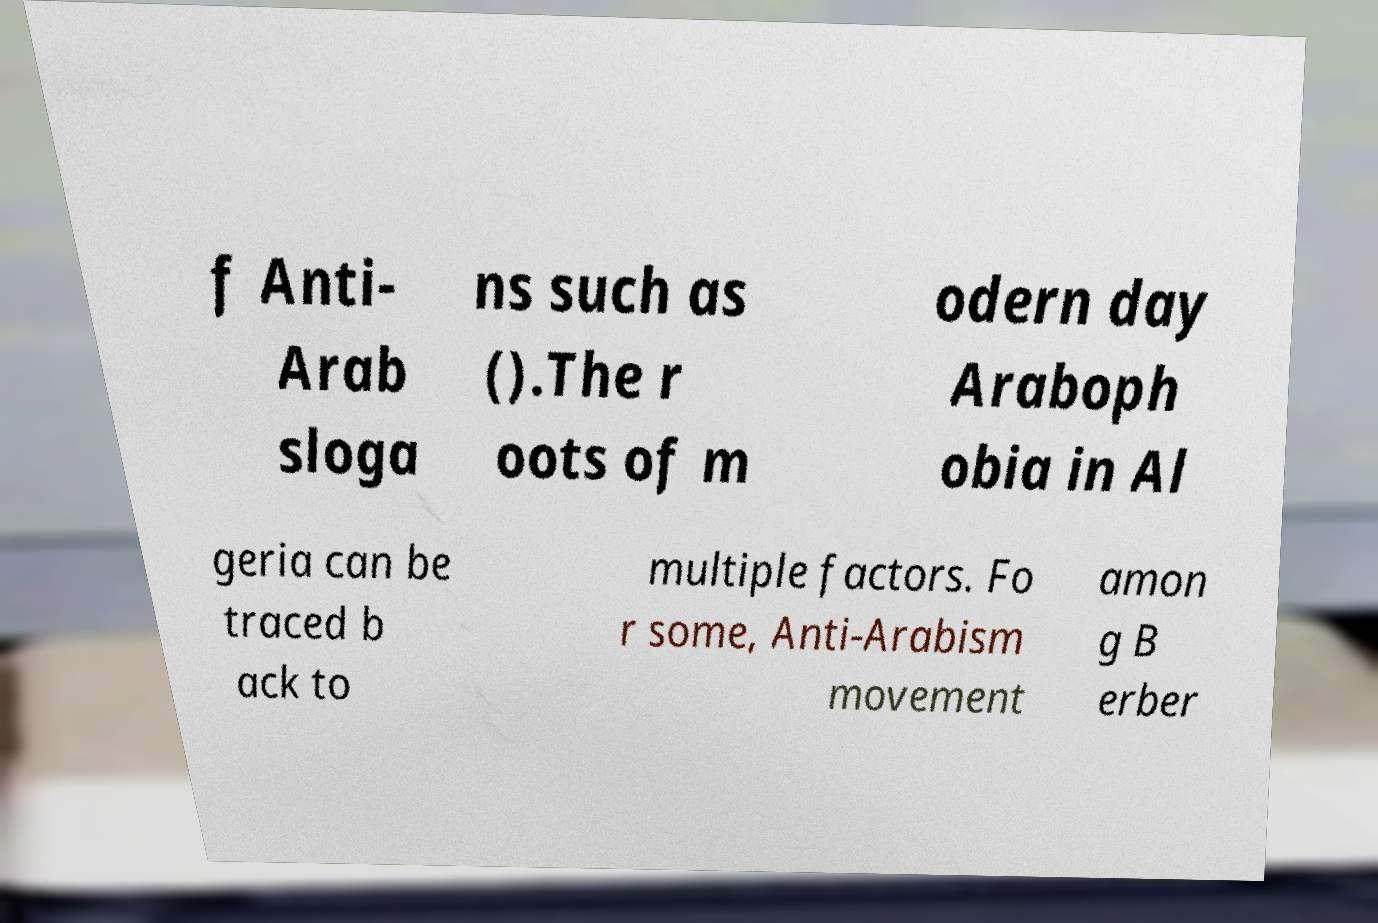For documentation purposes, I need the text within this image transcribed. Could you provide that? f Anti- Arab sloga ns such as ().The r oots of m odern day Araboph obia in Al geria can be traced b ack to multiple factors. Fo r some, Anti-Arabism movement amon g B erber 